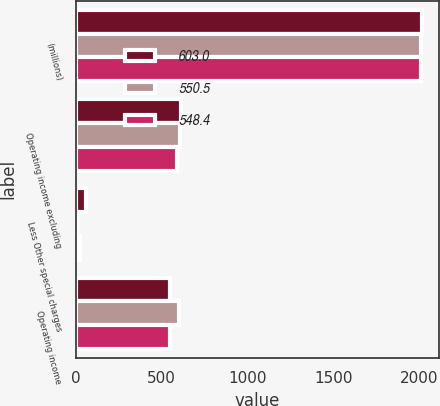<chart> <loc_0><loc_0><loc_500><loc_500><stacked_bar_chart><ecel><fcel>(millions)<fcel>Operating income excluding<fcel>Less Other special charges<fcel>Operating income<nl><fcel>603<fcel>2015<fcel>613.9<fcel>61.5<fcel>548.4<nl><fcel>550.5<fcel>2014<fcel>608.2<fcel>5.2<fcel>603<nl><fcel>548.4<fcel>2013<fcel>590.8<fcel>25<fcel>550.5<nl></chart> 